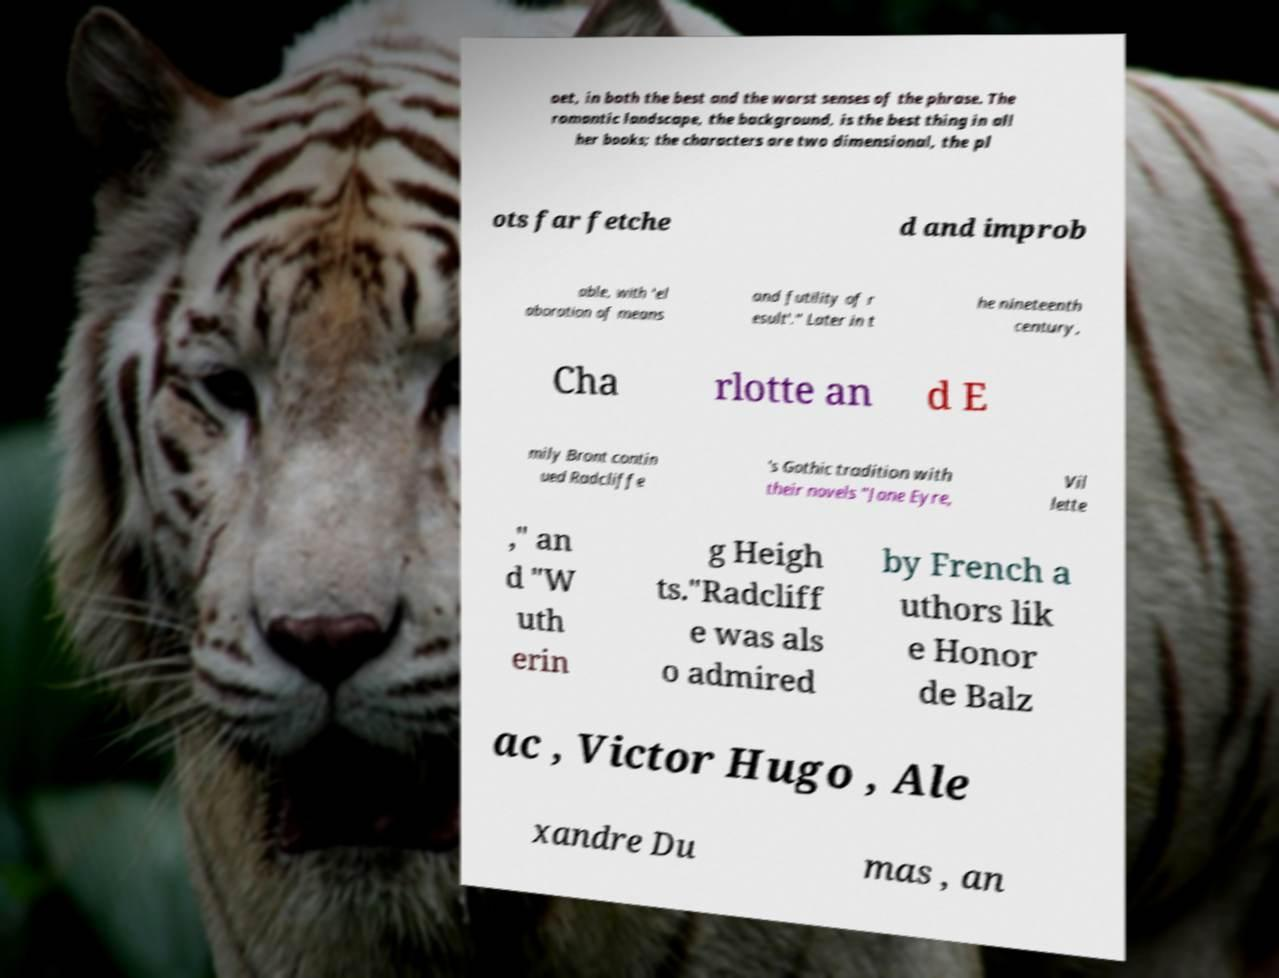There's text embedded in this image that I need extracted. Can you transcribe it verbatim? oet, in both the best and the worst senses of the phrase. The romantic landscape, the background, is the best thing in all her books; the characters are two dimensional, the pl ots far fetche d and improb able, with 'el aboration of means and futility of r esult'." Later in t he nineteenth century, Cha rlotte an d E mily Bront contin ued Radcliffe 's Gothic tradition with their novels "Jane Eyre, Vil lette ," an d "W uth erin g Heigh ts."Radcliff e was als o admired by French a uthors lik e Honor de Balz ac , Victor Hugo , Ale xandre Du mas , an 